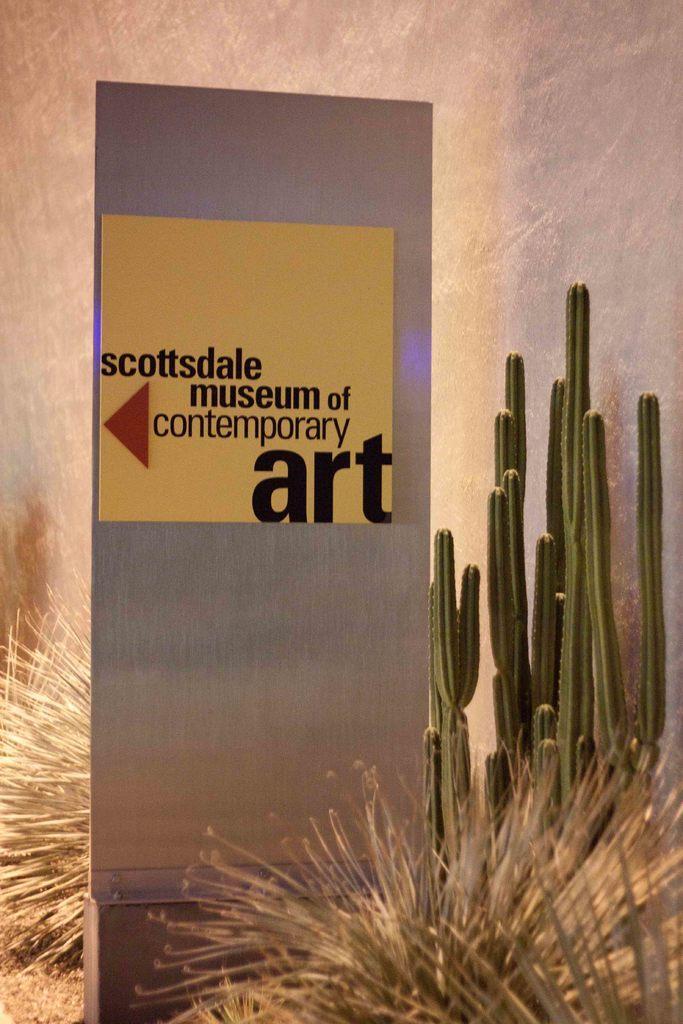In one or two sentences, can you explain what this image depicts? In this image I see a silver color thing on which there is something written over here and I see the cactus over here and I see few other plants. 